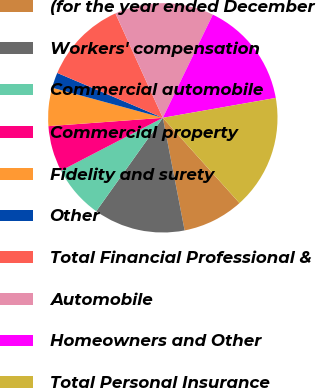Convert chart to OTSL. <chart><loc_0><loc_0><loc_500><loc_500><pie_chart><fcel>(for the year ended December<fcel>Workers' compensation<fcel>Commercial automobile<fcel>Commercial property<fcel>Fidelity and surety<fcel>Other<fcel>Total Financial Professional &<fcel>Automobile<fcel>Homeowners and Other<fcel>Total Personal Insurance<nl><fcel>8.61%<fcel>12.9%<fcel>7.53%<fcel>6.46%<fcel>5.39%<fcel>2.17%<fcel>11.82%<fcel>13.97%<fcel>15.04%<fcel>16.12%<nl></chart> 